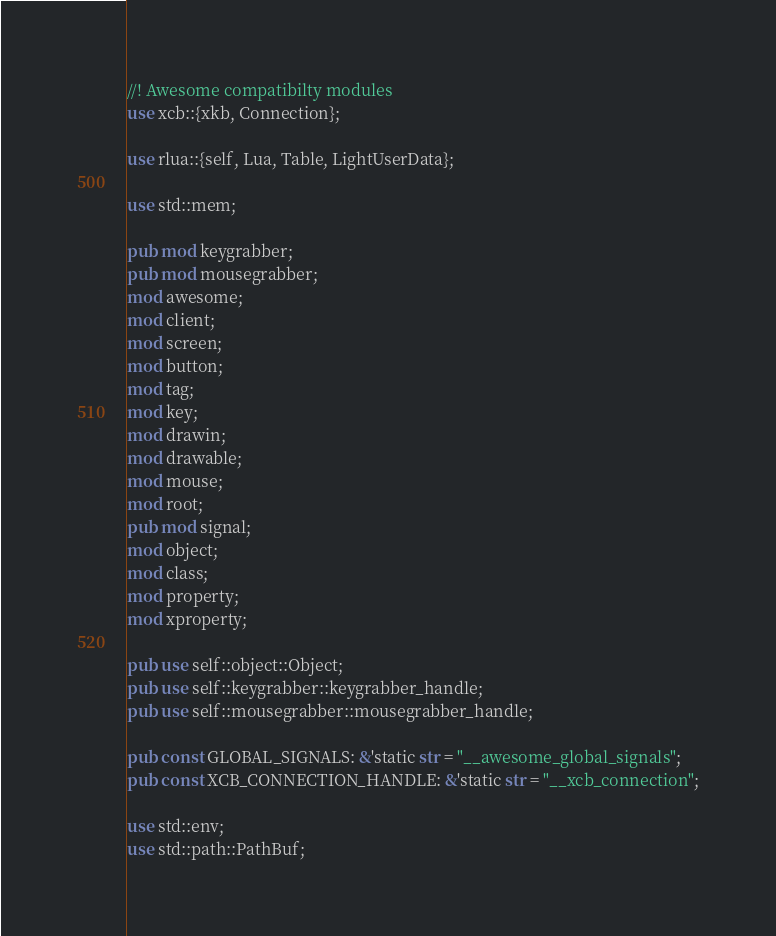Convert code to text. <code><loc_0><loc_0><loc_500><loc_500><_Rust_>//! Awesome compatibilty modules
use xcb::{xkb, Connection};

use rlua::{self, Lua, Table, LightUserData};

use std::mem;

pub mod keygrabber;
pub mod mousegrabber;
mod awesome;
mod client;
mod screen;
mod button;
mod tag;
mod key;
mod drawin;
mod drawable;
mod mouse;
mod root;
pub mod signal;
mod object;
mod class;
mod property;
mod xproperty;

pub use self::object::Object;
pub use self::keygrabber::keygrabber_handle;
pub use self::mousegrabber::mousegrabber_handle;

pub const GLOBAL_SIGNALS: &'static str = "__awesome_global_signals";
pub const XCB_CONNECTION_HANDLE: &'static str = "__xcb_connection";

use std::env;
use std::path::PathBuf;
</code> 